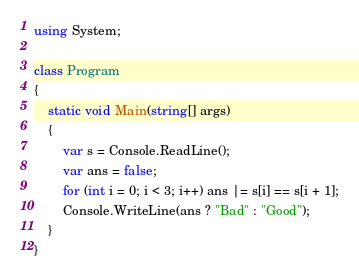<code> <loc_0><loc_0><loc_500><loc_500><_C#_>using System;

class Program
{
    static void Main(string[] args)
    {
        var s = Console.ReadLine();
        var ans = false;
        for (int i = 0; i < 3; i++) ans |= s[i] == s[i + 1];
        Console.WriteLine(ans ? "Bad" : "Good");
    }
}
</code> 